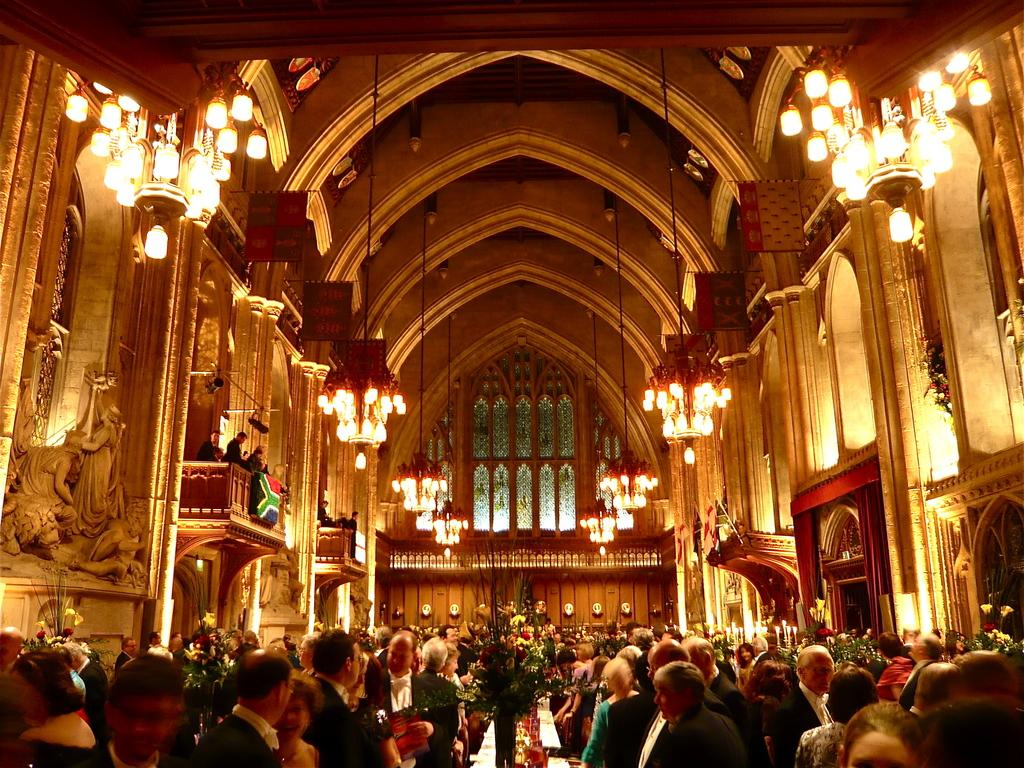What is the main focus of the image? The main focus of the image is a group of people in the center. What can be seen in the background of the image? In the background, there is a wall, a fence, a roof, lights, people, and other objects. Can you describe the setting of the image? The image appears to be set in an outdoor area with a wall, fence, and roof visible in the background. How many people are visible in the image? There are people in both the foreground and background of the image, but the exact number cannot be determined from the provided facts. What type of hat is the quarter wearing in the image? There is no hat or quarter present in the image. 